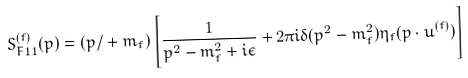<formula> <loc_0><loc_0><loc_500><loc_500>S ^ { ( f ) } _ { F 1 1 } ( p ) = ( { p } { / } + m _ { f } ) \left [ \frac { 1 } { p ^ { 2 } - m _ { f } ^ { 2 } + i \epsilon } + 2 \pi i \delta ( p ^ { 2 } - m _ { f } ^ { 2 } ) \eta _ { f } ( p \cdot u ^ { ( f ) } ) \right ]</formula> 